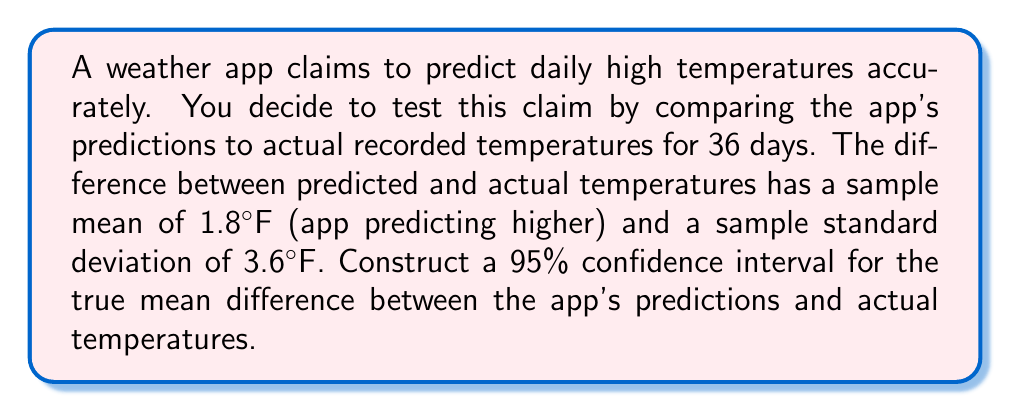Can you answer this question? To construct a confidence interval for the mean difference, we'll use the t-distribution since we don't know the population standard deviation. Here are the steps:

1. Identify the given information:
   - Sample size: $n = 36$
   - Sample mean difference: $\bar{x} = 1.8°F$
   - Sample standard deviation: $s = 3.6°F$
   - Confidence level: 95% (α = 0.05)

2. Find the degrees of freedom:
   $df = n - 1 = 36 - 1 = 35$

3. Determine the t-critical value for a 95% confidence interval with 35 degrees of freedom:
   $t_{0.025, 35} = 2.030$ (from t-distribution table)

4. Calculate the standard error of the mean:
   $SE = \frac{s}{\sqrt{n}} = \frac{3.6}{\sqrt{36}} = 0.6$

5. Compute the margin of error:
   $ME = t_{0.025, 35} \cdot SE = 2.030 \cdot 0.6 = 1.218$

6. Calculate the confidence interval:
   Lower bound: $\bar{x} - ME = 1.8 - 1.218 = 0.582$
   Upper bound: $\bar{x} + ME = 1.8 + 1.218 = 3.018$

Therefore, the 95% confidence interval for the true mean difference between the app's predictions and actual temperatures is (0.582°F, 3.018°F).
Answer: (0.582°F, 3.018°F) 